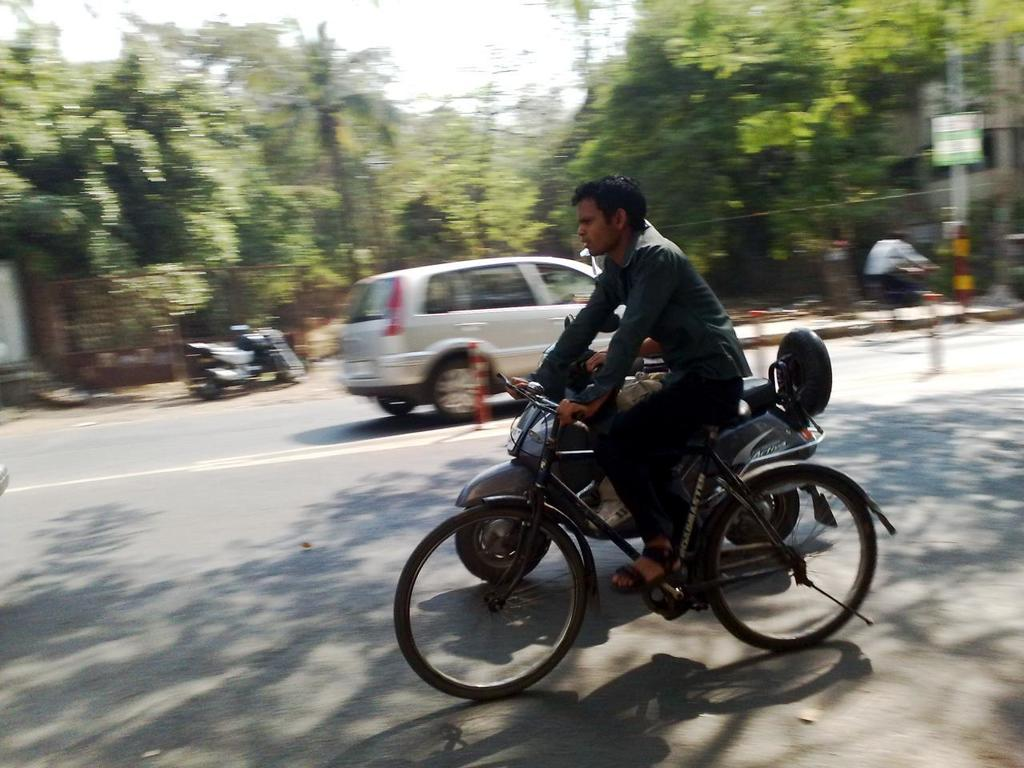What is the man in the image doing? The man is riding a bicycle in the image. What other vehicle is present in the image? There is a motorbike beside the man. What can be seen on the road in the image? There are vehicles on the road in the image. What is visible in the distance in the image? There are trees visible in the distance. What committee is the man on the bicycle a part of in the image? There is no mention of a committee in the image, and the man is simply riding a bicycle. How does the man lock his bicycle in the image? There is no indication of the man locking his bicycle in the image; he is actively riding it. 